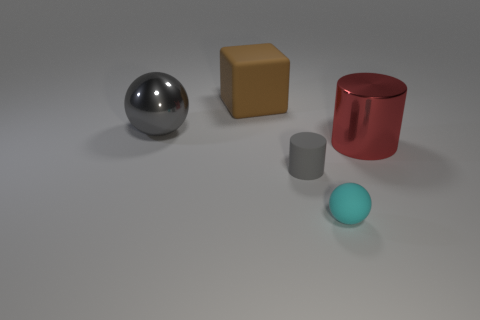There is a metallic thing on the left side of the block; what number of gray metal balls are behind it?
Provide a succinct answer. 0. What is the material of the object that is behind the small matte cylinder and in front of the big gray thing?
Provide a short and direct response. Metal. Do the large shiny thing that is to the right of the gray metal ball and the tiny gray thing have the same shape?
Offer a terse response. Yes. Is the number of gray shiny objects less than the number of big cyan rubber cubes?
Offer a very short reply. No. What number of things are the same color as the metallic sphere?
Your response must be concise. 1. What is the material of the small object that is the same color as the large shiny sphere?
Provide a short and direct response. Rubber. There is a large sphere; is it the same color as the tiny thing that is on the left side of the cyan matte sphere?
Your answer should be very brief. Yes. Are there more large metal balls than large blue balls?
Your answer should be compact. Yes. What size is the gray thing that is the same shape as the tiny cyan object?
Keep it short and to the point. Large. Are the large brown object and the big thing that is to the left of the large matte cube made of the same material?
Offer a terse response. No. 